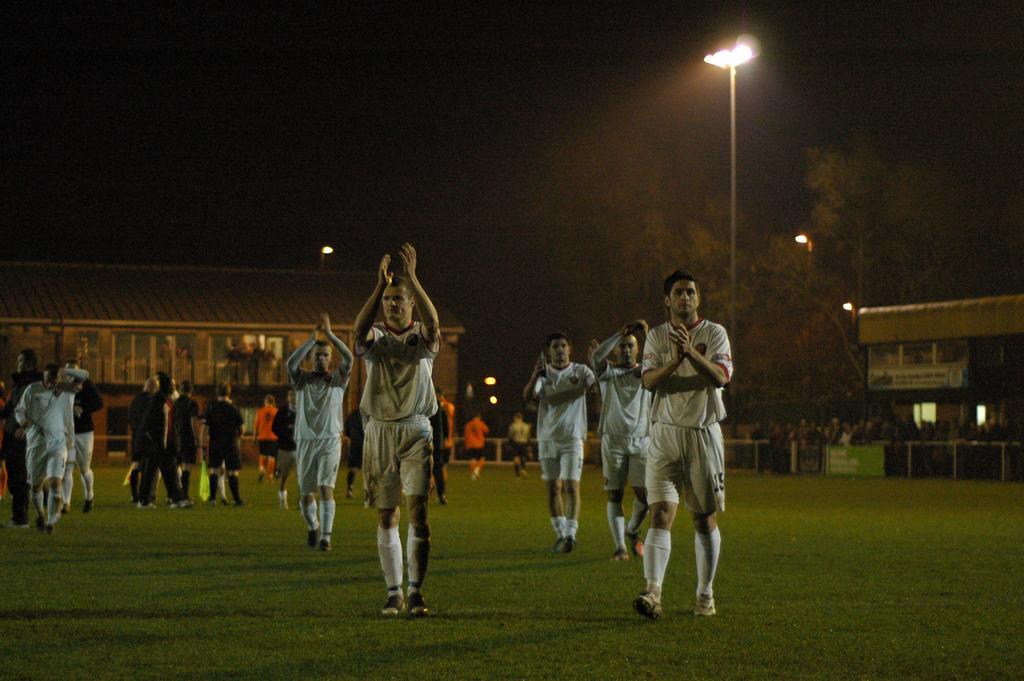Please provide a concise description of this image. In this image I can see the group of people wearing the different color dresses. These people are on the ground. In the background I can see the sheds, light poles, boards and many trees. And there is a black background. 